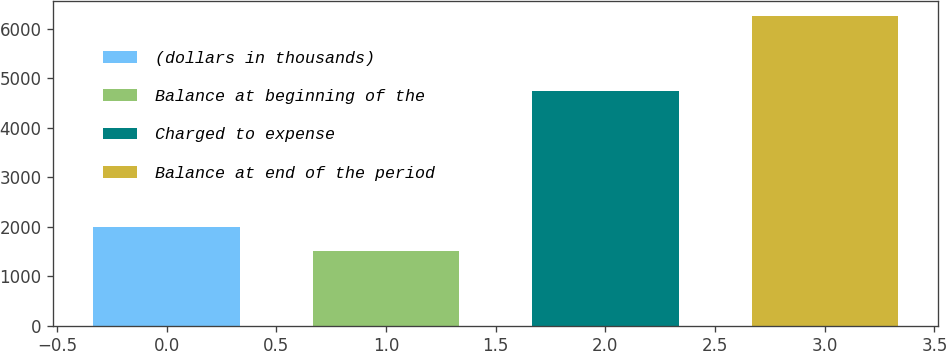<chart> <loc_0><loc_0><loc_500><loc_500><bar_chart><fcel>(dollars in thousands)<fcel>Balance at beginning of the<fcel>Charged to expense<fcel>Balance at end of the period<nl><fcel>2003<fcel>1510<fcel>4745<fcel>6255<nl></chart> 